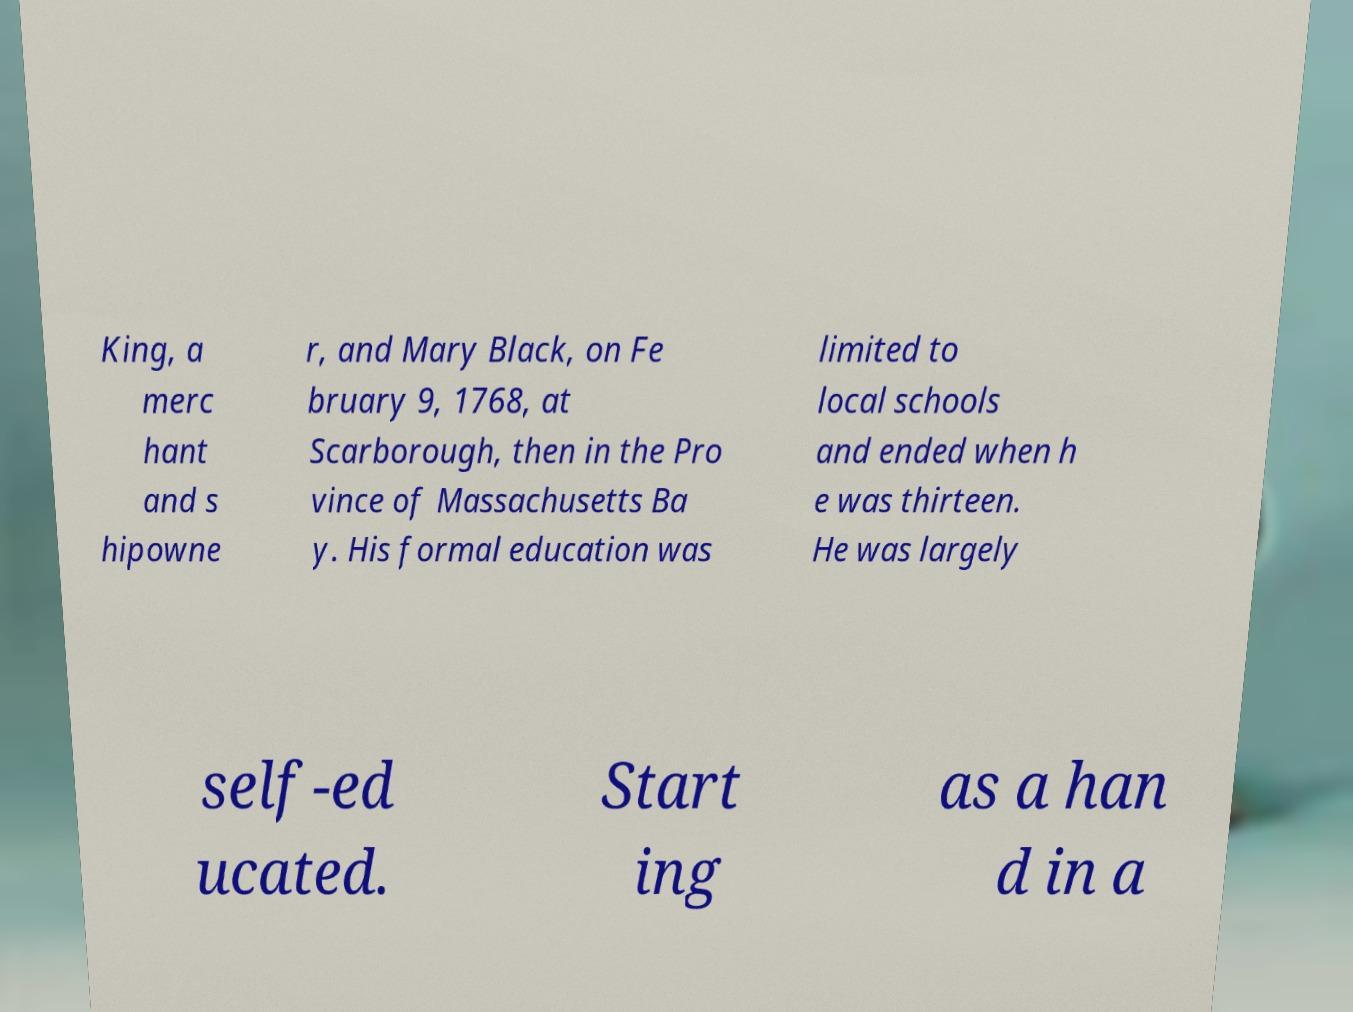For documentation purposes, I need the text within this image transcribed. Could you provide that? King, a merc hant and s hipowne r, and Mary Black, on Fe bruary 9, 1768, at Scarborough, then in the Pro vince of Massachusetts Ba y. His formal education was limited to local schools and ended when h e was thirteen. He was largely self-ed ucated. Start ing as a han d in a 